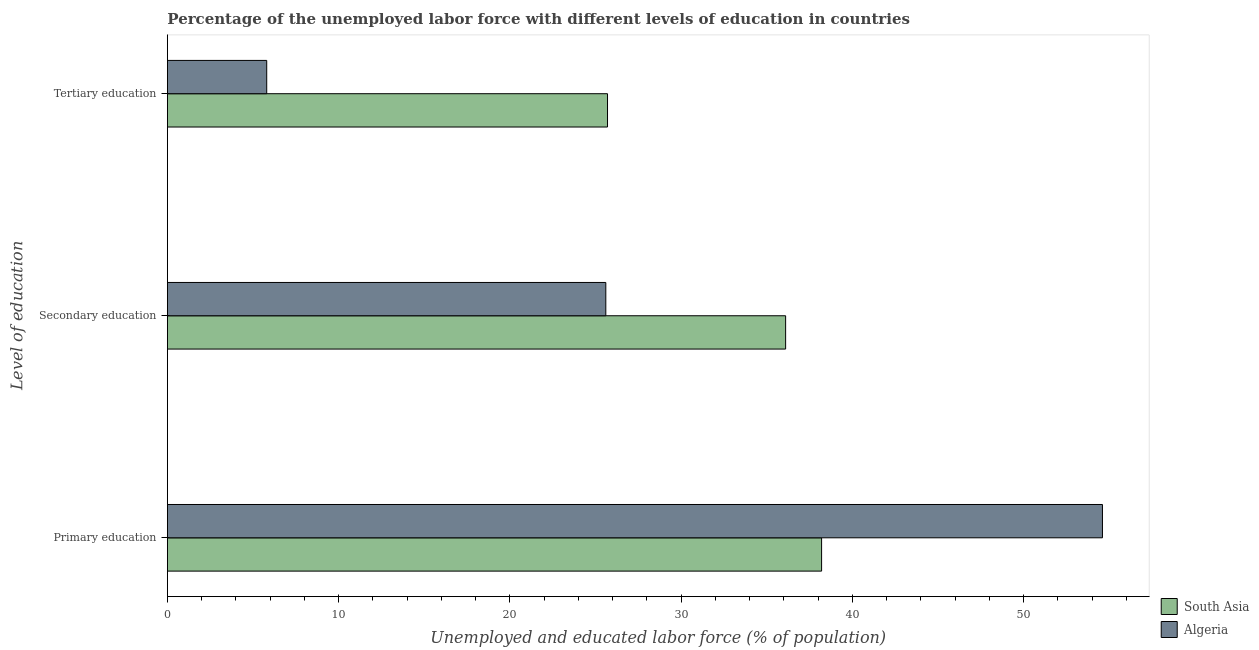How many groups of bars are there?
Your response must be concise. 3. Are the number of bars per tick equal to the number of legend labels?
Your answer should be compact. Yes. How many bars are there on the 1st tick from the top?
Offer a very short reply. 2. How many bars are there on the 1st tick from the bottom?
Ensure brevity in your answer.  2. What is the label of the 1st group of bars from the top?
Offer a terse response. Tertiary education. What is the percentage of labor force who received secondary education in South Asia?
Offer a very short reply. 36.1. Across all countries, what is the maximum percentage of labor force who received primary education?
Offer a very short reply. 54.6. Across all countries, what is the minimum percentage of labor force who received primary education?
Make the answer very short. 38.2. What is the total percentage of labor force who received secondary education in the graph?
Keep it short and to the point. 61.7. What is the difference between the percentage of labor force who received secondary education in Algeria and that in South Asia?
Offer a very short reply. -10.5. What is the difference between the percentage of labor force who received secondary education in Algeria and the percentage of labor force who received primary education in South Asia?
Provide a succinct answer. -12.6. What is the average percentage of labor force who received primary education per country?
Your answer should be very brief. 46.4. What is the difference between the percentage of labor force who received primary education and percentage of labor force who received secondary education in South Asia?
Provide a short and direct response. 2.1. What is the ratio of the percentage of labor force who received tertiary education in Algeria to that in South Asia?
Ensure brevity in your answer.  0.23. What is the difference between the highest and the second highest percentage of labor force who received tertiary education?
Your response must be concise. 19.9. What is the difference between the highest and the lowest percentage of labor force who received primary education?
Provide a succinct answer. 16.4. In how many countries, is the percentage of labor force who received tertiary education greater than the average percentage of labor force who received tertiary education taken over all countries?
Your answer should be very brief. 1. What does the 1st bar from the top in Secondary education represents?
Your answer should be compact. Algeria. What does the 2nd bar from the bottom in Tertiary education represents?
Ensure brevity in your answer.  Algeria. How many bars are there?
Ensure brevity in your answer.  6. Are all the bars in the graph horizontal?
Make the answer very short. Yes. How many countries are there in the graph?
Offer a terse response. 2. Are the values on the major ticks of X-axis written in scientific E-notation?
Keep it short and to the point. No. Where does the legend appear in the graph?
Your answer should be compact. Bottom right. How many legend labels are there?
Ensure brevity in your answer.  2. How are the legend labels stacked?
Offer a terse response. Vertical. What is the title of the graph?
Keep it short and to the point. Percentage of the unemployed labor force with different levels of education in countries. Does "Belarus" appear as one of the legend labels in the graph?
Your answer should be very brief. No. What is the label or title of the X-axis?
Keep it short and to the point. Unemployed and educated labor force (% of population). What is the label or title of the Y-axis?
Provide a succinct answer. Level of education. What is the Unemployed and educated labor force (% of population) of South Asia in Primary education?
Offer a terse response. 38.2. What is the Unemployed and educated labor force (% of population) of Algeria in Primary education?
Offer a very short reply. 54.6. What is the Unemployed and educated labor force (% of population) in South Asia in Secondary education?
Make the answer very short. 36.1. What is the Unemployed and educated labor force (% of population) in Algeria in Secondary education?
Your answer should be very brief. 25.6. What is the Unemployed and educated labor force (% of population) of South Asia in Tertiary education?
Your response must be concise. 25.7. What is the Unemployed and educated labor force (% of population) of Algeria in Tertiary education?
Provide a short and direct response. 5.8. Across all Level of education, what is the maximum Unemployed and educated labor force (% of population) in South Asia?
Your response must be concise. 38.2. Across all Level of education, what is the maximum Unemployed and educated labor force (% of population) in Algeria?
Keep it short and to the point. 54.6. Across all Level of education, what is the minimum Unemployed and educated labor force (% of population) in South Asia?
Offer a very short reply. 25.7. Across all Level of education, what is the minimum Unemployed and educated labor force (% of population) in Algeria?
Provide a succinct answer. 5.8. What is the total Unemployed and educated labor force (% of population) in Algeria in the graph?
Offer a terse response. 86. What is the difference between the Unemployed and educated labor force (% of population) in South Asia in Primary education and that in Secondary education?
Make the answer very short. 2.1. What is the difference between the Unemployed and educated labor force (% of population) in Algeria in Primary education and that in Secondary education?
Give a very brief answer. 29. What is the difference between the Unemployed and educated labor force (% of population) in Algeria in Primary education and that in Tertiary education?
Make the answer very short. 48.8. What is the difference between the Unemployed and educated labor force (% of population) of Algeria in Secondary education and that in Tertiary education?
Your response must be concise. 19.8. What is the difference between the Unemployed and educated labor force (% of population) of South Asia in Primary education and the Unemployed and educated labor force (% of population) of Algeria in Tertiary education?
Ensure brevity in your answer.  32.4. What is the difference between the Unemployed and educated labor force (% of population) in South Asia in Secondary education and the Unemployed and educated labor force (% of population) in Algeria in Tertiary education?
Make the answer very short. 30.3. What is the average Unemployed and educated labor force (% of population) in South Asia per Level of education?
Ensure brevity in your answer.  33.33. What is the average Unemployed and educated labor force (% of population) of Algeria per Level of education?
Provide a succinct answer. 28.67. What is the difference between the Unemployed and educated labor force (% of population) in South Asia and Unemployed and educated labor force (% of population) in Algeria in Primary education?
Offer a terse response. -16.4. What is the difference between the Unemployed and educated labor force (% of population) in South Asia and Unemployed and educated labor force (% of population) in Algeria in Tertiary education?
Provide a short and direct response. 19.9. What is the ratio of the Unemployed and educated labor force (% of population) in South Asia in Primary education to that in Secondary education?
Keep it short and to the point. 1.06. What is the ratio of the Unemployed and educated labor force (% of population) in Algeria in Primary education to that in Secondary education?
Offer a very short reply. 2.13. What is the ratio of the Unemployed and educated labor force (% of population) in South Asia in Primary education to that in Tertiary education?
Make the answer very short. 1.49. What is the ratio of the Unemployed and educated labor force (% of population) of Algeria in Primary education to that in Tertiary education?
Ensure brevity in your answer.  9.41. What is the ratio of the Unemployed and educated labor force (% of population) in South Asia in Secondary education to that in Tertiary education?
Keep it short and to the point. 1.4. What is the ratio of the Unemployed and educated labor force (% of population) of Algeria in Secondary education to that in Tertiary education?
Offer a terse response. 4.41. What is the difference between the highest and the second highest Unemployed and educated labor force (% of population) in Algeria?
Give a very brief answer. 29. What is the difference between the highest and the lowest Unemployed and educated labor force (% of population) of South Asia?
Your answer should be compact. 12.5. What is the difference between the highest and the lowest Unemployed and educated labor force (% of population) of Algeria?
Provide a succinct answer. 48.8. 